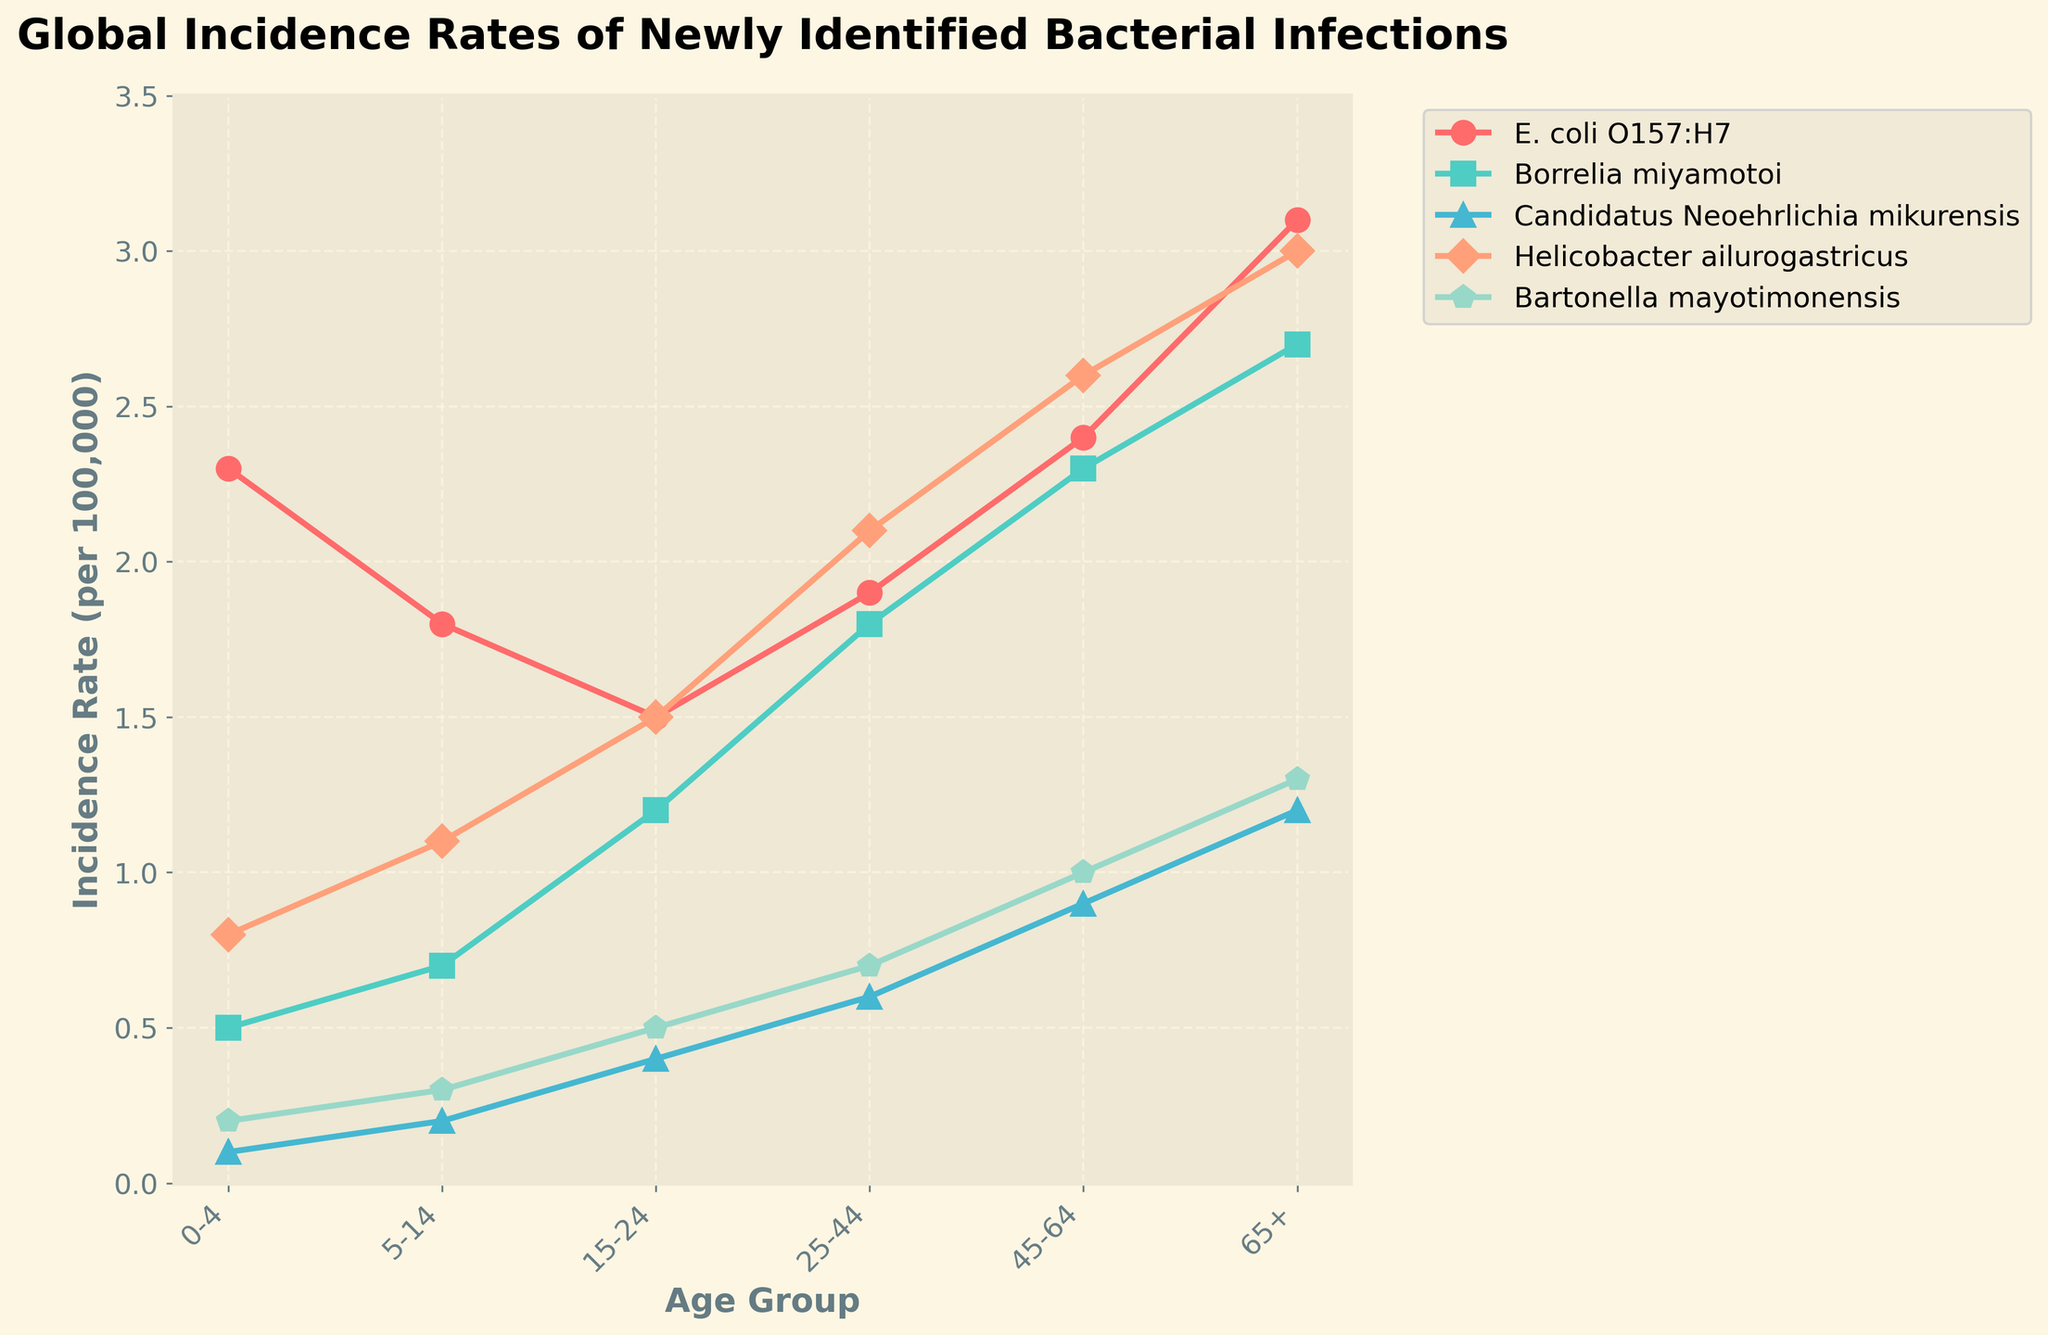What is the incidence rate of Borrelia miyamotoi in the 45-64 age group? Look for the value on the line representing Borrelia miyamotoi (blue color with square markers) at the 45-64 age group.
Answer: 2.3 Which bacterial strain has the highest incidence rate in the 65+ age group? Compare the incidence rates of all bacterial strains in the 65+ age group. The one with the highest value is the answer.
Answer: E. coli O157:H7 What is the average incidence rate of Helicobacter ailurogastricus across all age groups? Sum the incidence rates of Helicobacter ailurogastricus (red color with diamond markers) across all age groups and divide by the number of age groups (6). (0.8 + 1.1 + 1.5 + 2.1 + 2.6 + 3.0) / 6 = 11.1 / 6
Answer: 1.85 How does the incidence rate of Candidatus Neoehrlichia mikurensis in the 0-4 age group compare to the 65+ age group? Look at the incidence rates of Candidatus Neoehrlichia mikurensis (green color with triangle markers) for both age groups, then compare: 0.1 in 0-4 and 1.2 in 65+.
Answer: The incidence rate is higher in the 65+ age group Is the incidence rate of Bartonella mayotimonensis higher in the 25-44 age group or the 5-14 age group? Compare the incidence rates of Bartonella mayotimonensis (orange color with pentagon markers) in the 25-44 and 5-14 age groups: 0.7 in 25-44 and 0.3 in 5-14.
Answer: Higher in 25-44 Which age group has the lowest incidence rate of E. coli O157:H7? Look at the incidence rates of E. coli O157:H7 (pink color with circle markers) in all age groups and find the lowest: 1.5 in 15-24.
Answer: 15-24 What is the cumulative incidence rate of all bacterial strains in the 0-4 age group? Sum the incidence rates of all strains in the 0-4 age group: 2.3 (E. coli O157:H7) + 0.5 (Borrelia miyamotoi) + 0.1 (Candidatus Neoehrlichia mikurensis) + 0.8 (Helicobacter ailurogastricus) + 0.2 (Bartonella mayotimonensis) = 3.9.
Answer: 3.9 Compare the trend of incidence rates from the 0-4 age group to the 65+ age group for all strains. Which strain shows the most significant increase? Calculate the difference between the incidence rates for each strain from 0-4 to 65+: 
E. coli O157:H7: 3.1 - 2.3 = 0.8,
Borrelia miyamotoi: 2.7 - 0.5 = 2.2,
Candidatus Neoehrlichia mikurensis: 1.2 - 0.1 = 1.1,
Helicobacter ailurogastricus: 3.0 - 0.8 = 2.2,
Bartonella mayotimonensis: 1.3 - 0.2 = 1.1.
Borrelia miyamotoi and Helicobacter ailurogastricus both show the most significant increase (2.2).
Answer: Borrelia miyamotoi and Helicobacter ailurogastricus 